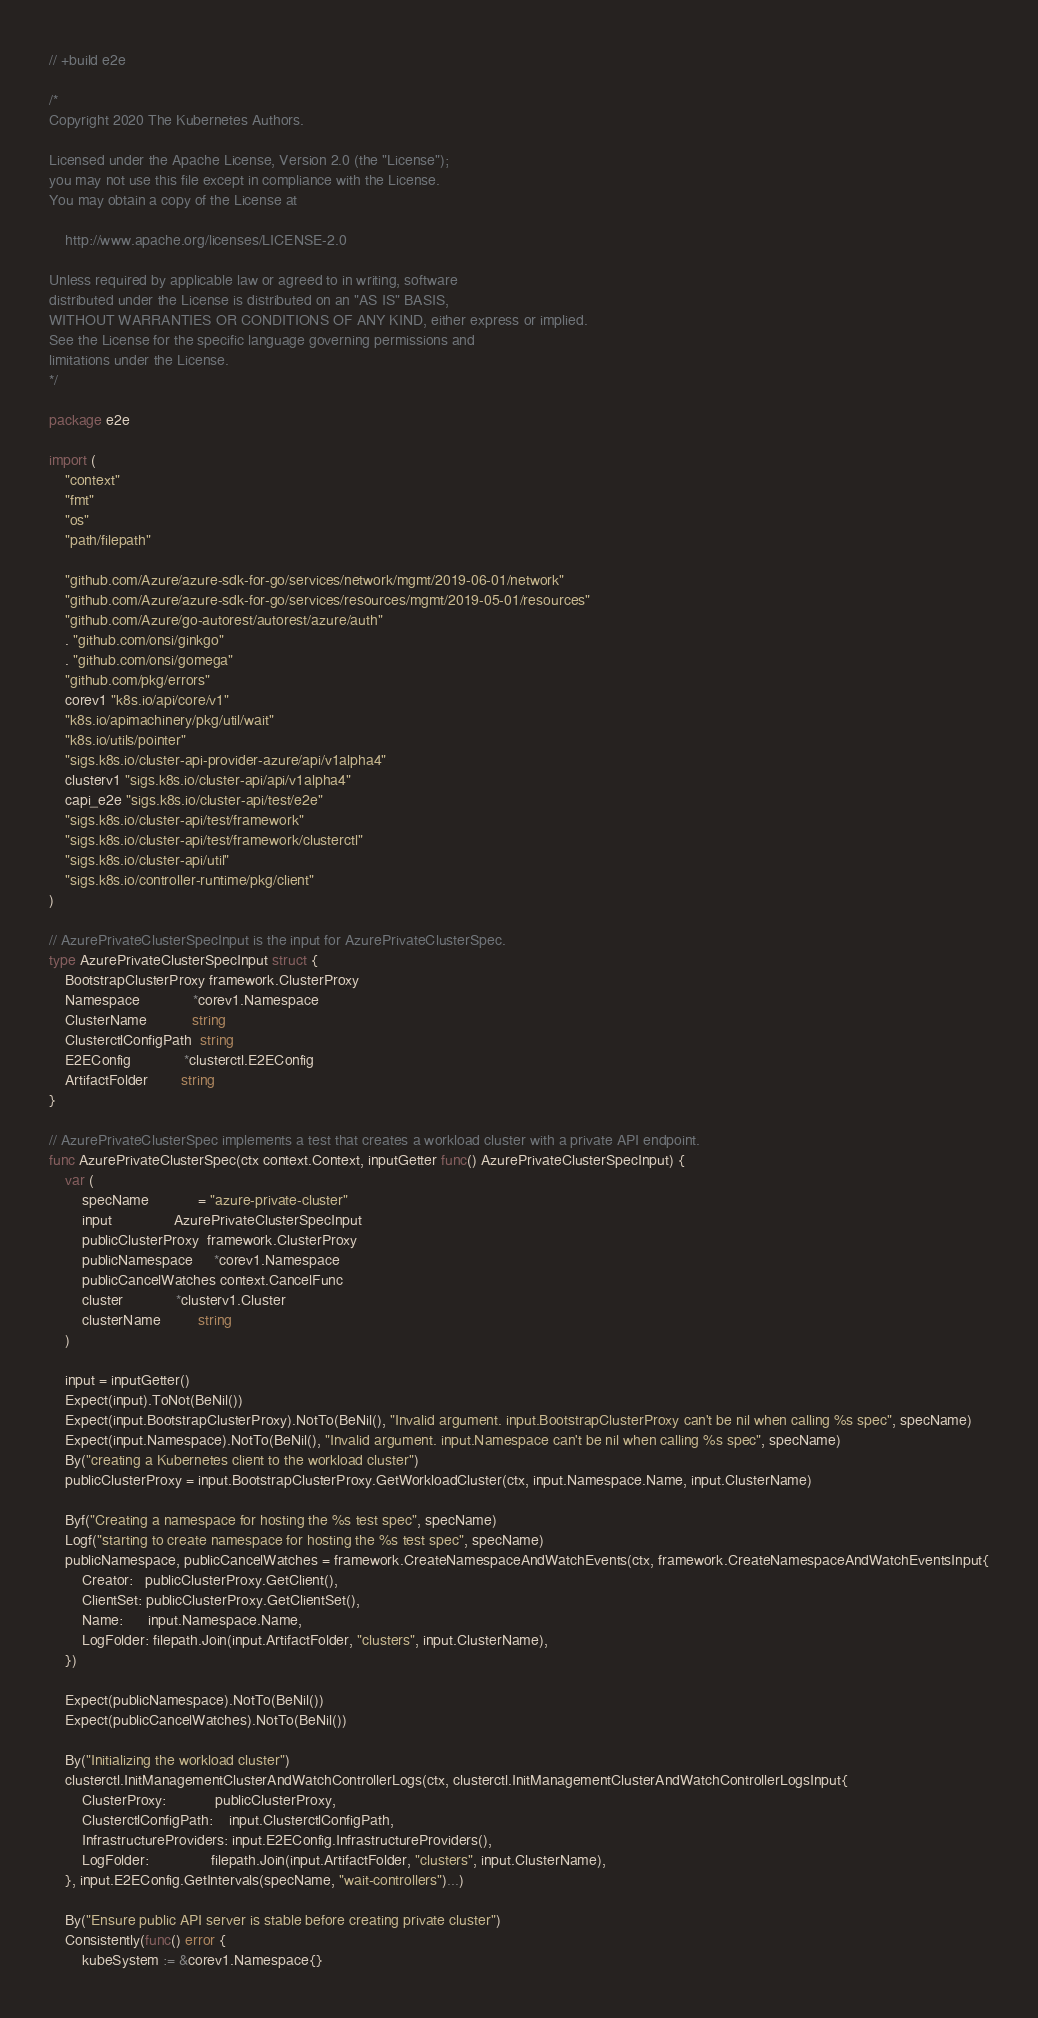Convert code to text. <code><loc_0><loc_0><loc_500><loc_500><_Go_>// +build e2e

/*
Copyright 2020 The Kubernetes Authors.

Licensed under the Apache License, Version 2.0 (the "License");
you may not use this file except in compliance with the License.
You may obtain a copy of the License at

    http://www.apache.org/licenses/LICENSE-2.0

Unless required by applicable law or agreed to in writing, software
distributed under the License is distributed on an "AS IS" BASIS,
WITHOUT WARRANTIES OR CONDITIONS OF ANY KIND, either express or implied.
See the License for the specific language governing permissions and
limitations under the License.
*/

package e2e

import (
	"context"
	"fmt"
	"os"
	"path/filepath"

	"github.com/Azure/azure-sdk-for-go/services/network/mgmt/2019-06-01/network"
	"github.com/Azure/azure-sdk-for-go/services/resources/mgmt/2019-05-01/resources"
	"github.com/Azure/go-autorest/autorest/azure/auth"
	. "github.com/onsi/ginkgo"
	. "github.com/onsi/gomega"
	"github.com/pkg/errors"
	corev1 "k8s.io/api/core/v1"
	"k8s.io/apimachinery/pkg/util/wait"
	"k8s.io/utils/pointer"
	"sigs.k8s.io/cluster-api-provider-azure/api/v1alpha4"
	clusterv1 "sigs.k8s.io/cluster-api/api/v1alpha4"
	capi_e2e "sigs.k8s.io/cluster-api/test/e2e"
	"sigs.k8s.io/cluster-api/test/framework"
	"sigs.k8s.io/cluster-api/test/framework/clusterctl"
	"sigs.k8s.io/cluster-api/util"
	"sigs.k8s.io/controller-runtime/pkg/client"
)

// AzurePrivateClusterSpecInput is the input for AzurePrivateClusterSpec.
type AzurePrivateClusterSpecInput struct {
	BootstrapClusterProxy framework.ClusterProxy
	Namespace             *corev1.Namespace
	ClusterName           string
	ClusterctlConfigPath  string
	E2EConfig             *clusterctl.E2EConfig
	ArtifactFolder        string
}

// AzurePrivateClusterSpec implements a test that creates a workload cluster with a private API endpoint.
func AzurePrivateClusterSpec(ctx context.Context, inputGetter func() AzurePrivateClusterSpecInput) {
	var (
		specName            = "azure-private-cluster"
		input               AzurePrivateClusterSpecInput
		publicClusterProxy  framework.ClusterProxy
		publicNamespace     *corev1.Namespace
		publicCancelWatches context.CancelFunc
		cluster             *clusterv1.Cluster
		clusterName         string
	)

	input = inputGetter()
	Expect(input).ToNot(BeNil())
	Expect(input.BootstrapClusterProxy).NotTo(BeNil(), "Invalid argument. input.BootstrapClusterProxy can't be nil when calling %s spec", specName)
	Expect(input.Namespace).NotTo(BeNil(), "Invalid argument. input.Namespace can't be nil when calling %s spec", specName)
	By("creating a Kubernetes client to the workload cluster")
	publicClusterProxy = input.BootstrapClusterProxy.GetWorkloadCluster(ctx, input.Namespace.Name, input.ClusterName)

	Byf("Creating a namespace for hosting the %s test spec", specName)
	Logf("starting to create namespace for hosting the %s test spec", specName)
	publicNamespace, publicCancelWatches = framework.CreateNamespaceAndWatchEvents(ctx, framework.CreateNamespaceAndWatchEventsInput{
		Creator:   publicClusterProxy.GetClient(),
		ClientSet: publicClusterProxy.GetClientSet(),
		Name:      input.Namespace.Name,
		LogFolder: filepath.Join(input.ArtifactFolder, "clusters", input.ClusterName),
	})

	Expect(publicNamespace).NotTo(BeNil())
	Expect(publicCancelWatches).NotTo(BeNil())

	By("Initializing the workload cluster")
	clusterctl.InitManagementClusterAndWatchControllerLogs(ctx, clusterctl.InitManagementClusterAndWatchControllerLogsInput{
		ClusterProxy:            publicClusterProxy,
		ClusterctlConfigPath:    input.ClusterctlConfigPath,
		InfrastructureProviders: input.E2EConfig.InfrastructureProviders(),
		LogFolder:               filepath.Join(input.ArtifactFolder, "clusters", input.ClusterName),
	}, input.E2EConfig.GetIntervals(specName, "wait-controllers")...)

	By("Ensure public API server is stable before creating private cluster")
	Consistently(func() error {
		kubeSystem := &corev1.Namespace{}</code> 